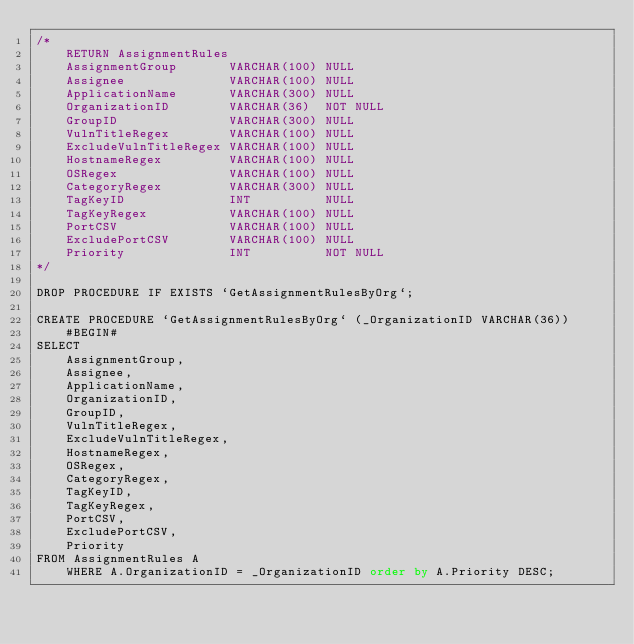Convert code to text. <code><loc_0><loc_0><loc_500><loc_500><_SQL_>/*
    RETURN AssignmentRules
    AssignmentGroup       VARCHAR(100) NULL
    Assignee              VARCHAR(100) NULL
    ApplicationName       VARCHAR(300) NULL
    OrganizationID        VARCHAR(36)  NOT NULL
    GroupID               VARCHAR(300) NULL
    VulnTitleRegex        VARCHAR(100) NULL
    ExcludeVulnTitleRegex VARCHAR(100) NULL
    HostnameRegex         VARCHAR(100) NULL
    OSRegex               VARCHAR(100) NULL
    CategoryRegex         VARCHAR(300) NULL
    TagKeyID              INT          NULL
    TagKeyRegex           VARCHAR(100) NULL
    PortCSV               VARCHAR(100) NULL
    ExcludePortCSV        VARCHAR(100) NULL
    Priority              INT          NOT NULL
*/

DROP PROCEDURE IF EXISTS `GetAssignmentRulesByOrg`;

CREATE PROCEDURE `GetAssignmentRulesByOrg` (_OrganizationID VARCHAR(36))
    #BEGIN#
SELECT
    AssignmentGroup,
    Assignee,
    ApplicationName,
    OrganizationID,
    GroupID,
    VulnTitleRegex,
    ExcludeVulnTitleRegex,
    HostnameRegex,
    OSRegex,
    CategoryRegex,
    TagKeyID,
    TagKeyRegex,
    PortCSV,
    ExcludePortCSV,
    Priority
FROM AssignmentRules A
    WHERE A.OrganizationID = _OrganizationID order by A.Priority DESC;
</code> 